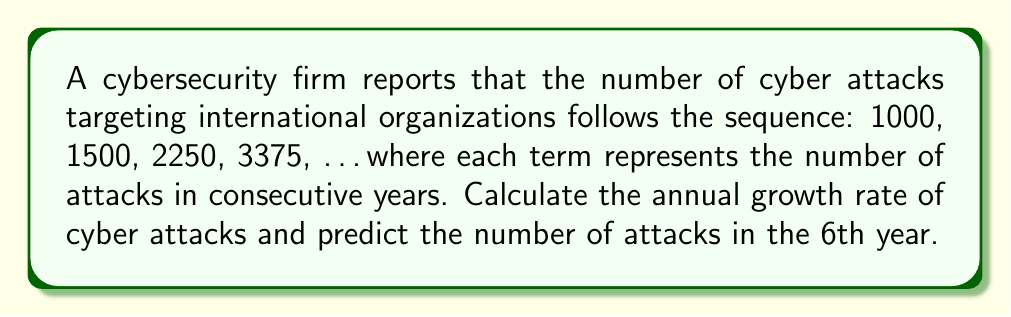What is the answer to this math problem? 1. Identify the pattern:
   Let's examine the ratio between consecutive terms:
   1500 / 1000 = 1.5
   2250 / 1500 = 1.5
   3375 / 2250 = 1.5

2. Determine the growth rate:
   The ratio 1.5 indicates a 50% increase each year.
   Growth rate = (New value - Original value) / Original value
   $$ \text{Growth rate} = \frac{1.5 - 1}{1} = 0.5 = 50\% $$

3. Express the sequence mathematically:
   $a_n = 1000 \times 1.5^{n-1}$, where $n$ is the year number.

4. Calculate the number of attacks in the 6th year:
   $$ a_6 = 1000 \times 1.5^{6-1} = 1000 \times 1.5^5 $$
   $$ = 1000 \times 7.59375 = 7593.75 $$

Therefore, in the 6th year, there will be 7,594 cyber attacks (rounded to the nearest whole number).
Answer: 50% annual growth rate; 7,594 attacks in 6th year 